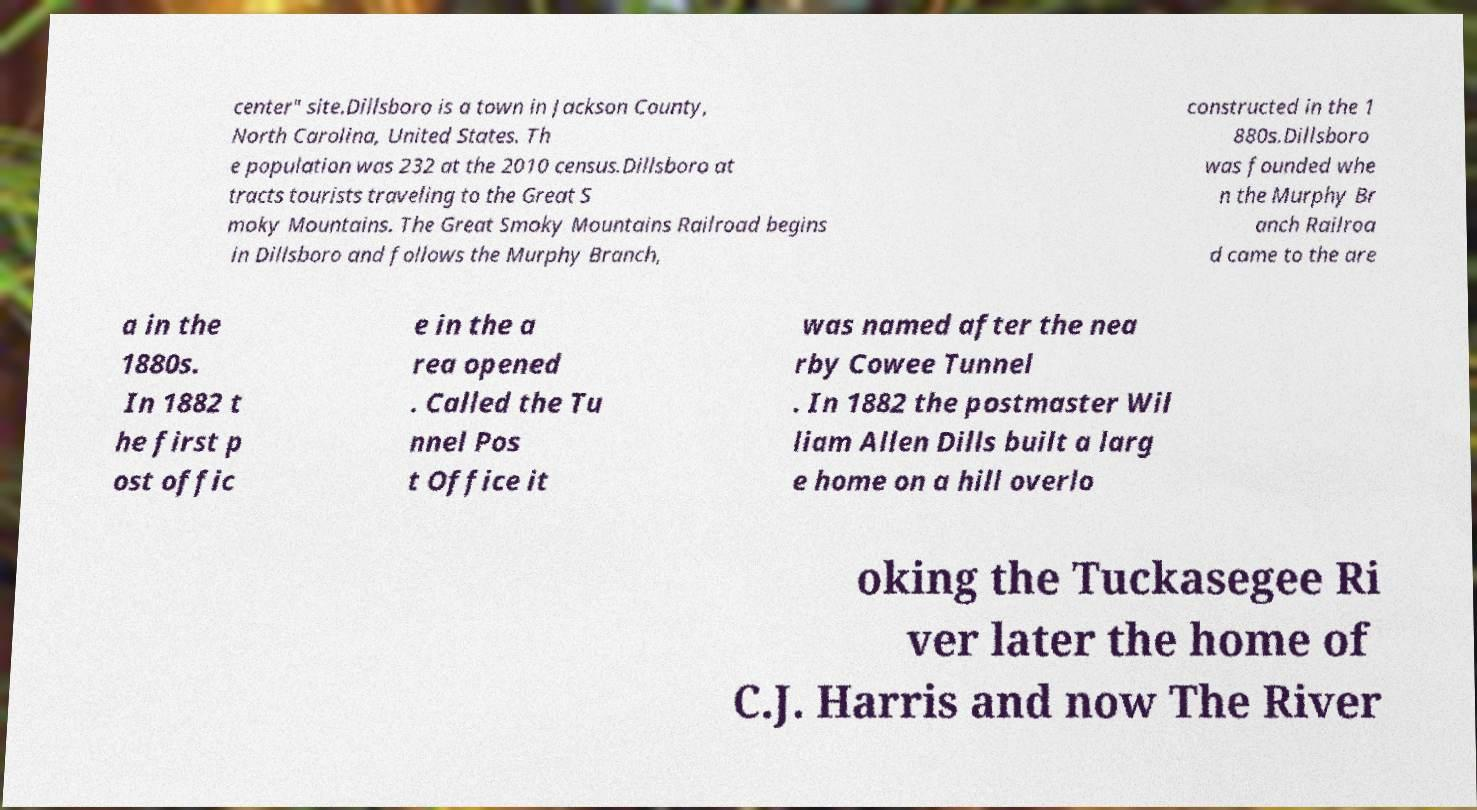I need the written content from this picture converted into text. Can you do that? center" site.Dillsboro is a town in Jackson County, North Carolina, United States. Th e population was 232 at the 2010 census.Dillsboro at tracts tourists traveling to the Great S moky Mountains. The Great Smoky Mountains Railroad begins in Dillsboro and follows the Murphy Branch, constructed in the 1 880s.Dillsboro was founded whe n the Murphy Br anch Railroa d came to the are a in the 1880s. In 1882 t he first p ost offic e in the a rea opened . Called the Tu nnel Pos t Office it was named after the nea rby Cowee Tunnel . In 1882 the postmaster Wil liam Allen Dills built a larg e home on a hill overlo oking the Tuckasegee Ri ver later the home of C.J. Harris and now The River 